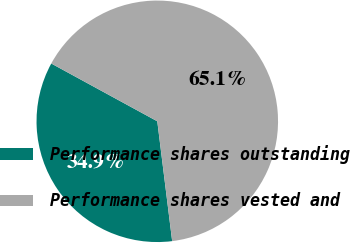<chart> <loc_0><loc_0><loc_500><loc_500><pie_chart><fcel>Performance shares outstanding<fcel>Performance shares vested and<nl><fcel>34.91%<fcel>65.09%<nl></chart> 